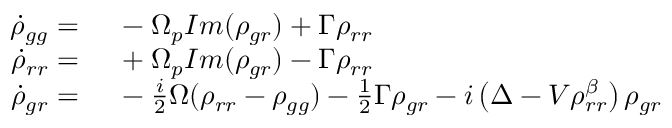<formula> <loc_0><loc_0><loc_500><loc_500>\begin{array} { r l } { \dot { \rho } _ { g g } = } & \ - \Omega _ { p } I m ( \rho _ { g r } ) + \Gamma \rho _ { r r } } \\ { \dot { \rho } _ { r r } = } & \ + \Omega _ { p } I m ( \rho _ { g r } ) - \Gamma \rho _ { r r } } \\ { \dot { \rho } _ { g r } = } & \ - \frac { i } { 2 } \Omega ( \rho _ { r r } - \rho _ { g g } ) - \frac { 1 } { 2 } \Gamma \rho _ { g r } - i \left ( \Delta - V \rho _ { r r } ^ { \beta } \right ) \rho _ { g r } } \end{array}</formula> 